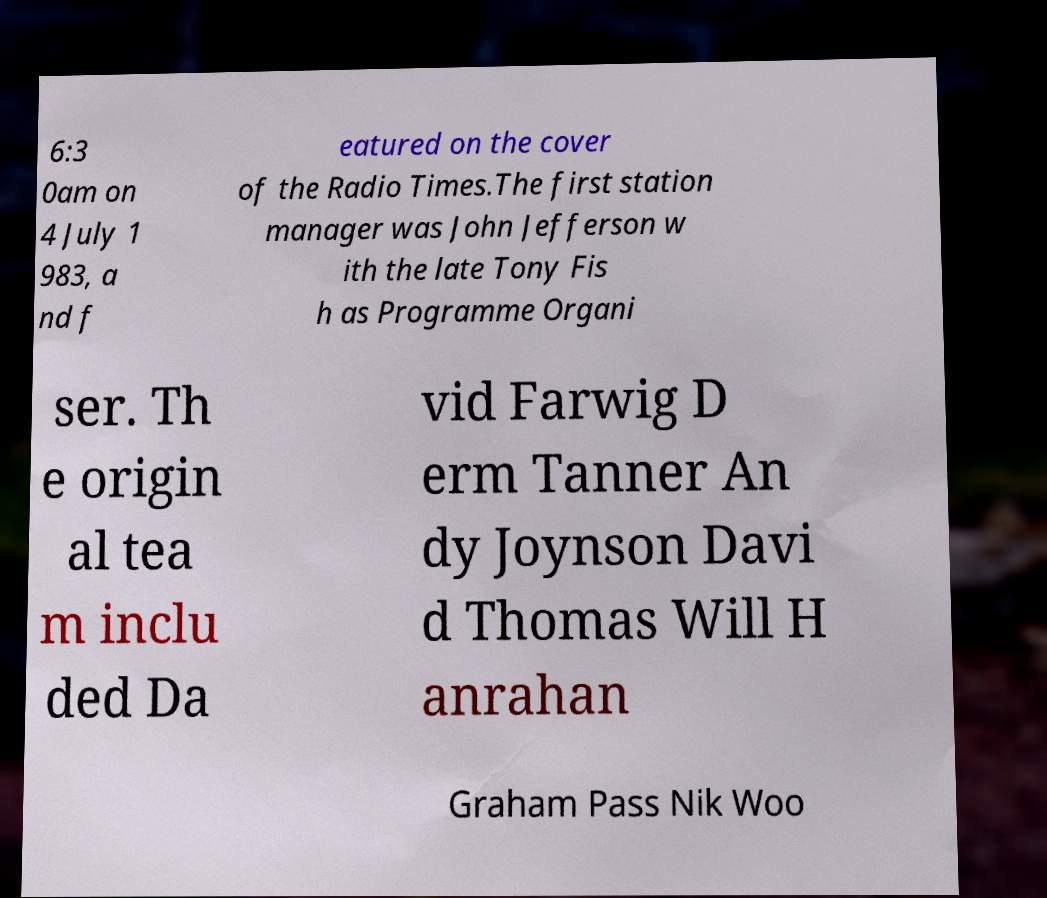Could you assist in decoding the text presented in this image and type it out clearly? 6:3 0am on 4 July 1 983, a nd f eatured on the cover of the Radio Times.The first station manager was John Jefferson w ith the late Tony Fis h as Programme Organi ser. Th e origin al tea m inclu ded Da vid Farwig D erm Tanner An dy Joynson Davi d Thomas Will H anrahan Graham Pass Nik Woo 